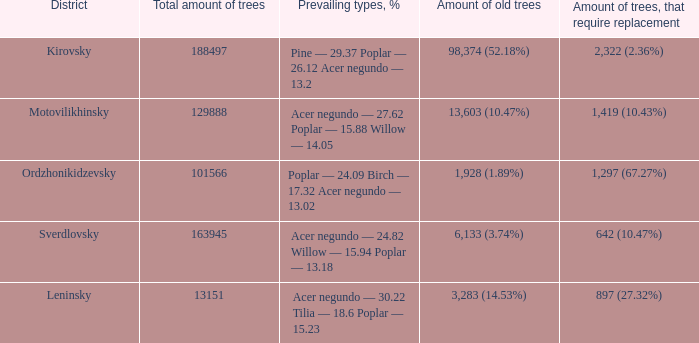2? 2,322 (2.36%). 